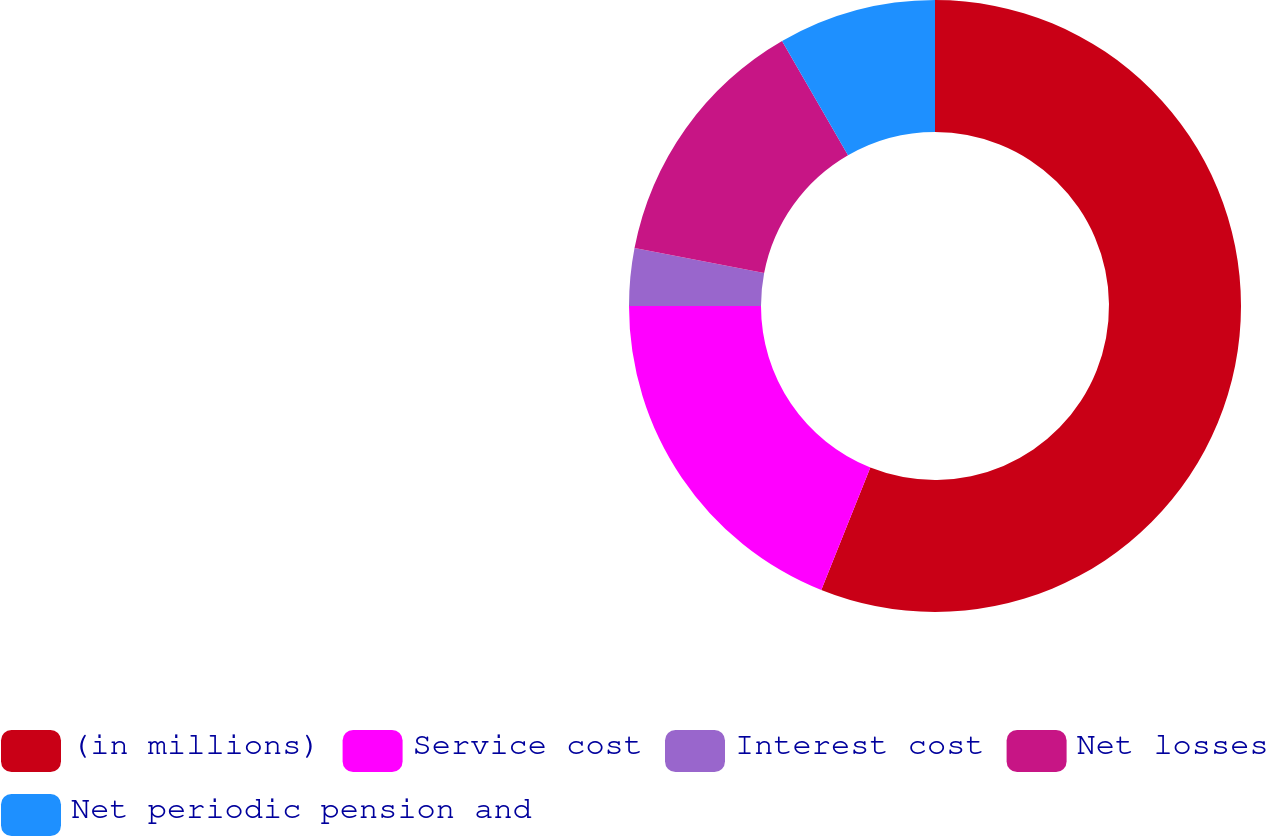Convert chart to OTSL. <chart><loc_0><loc_0><loc_500><loc_500><pie_chart><fcel>(in millions)<fcel>Service cost<fcel>Interest cost<fcel>Net losses<fcel>Net periodic pension and<nl><fcel>56.06%<fcel>18.94%<fcel>3.03%<fcel>13.64%<fcel>8.33%<nl></chart> 